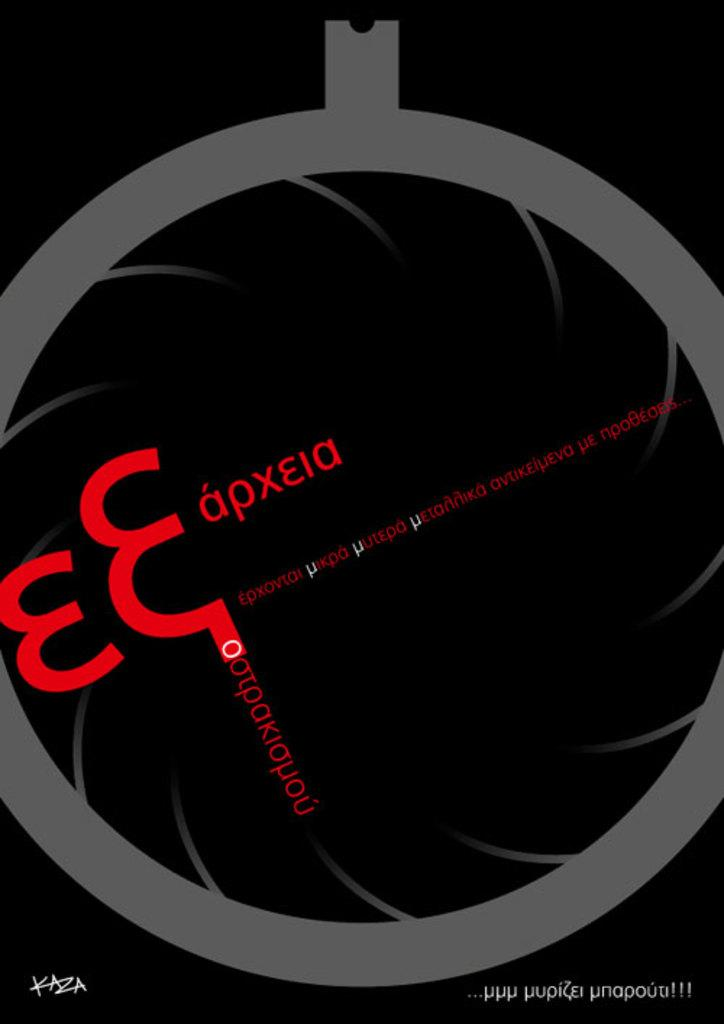<image>
Share a concise interpretation of the image provided. a graphic image with something that looks like an E on it 